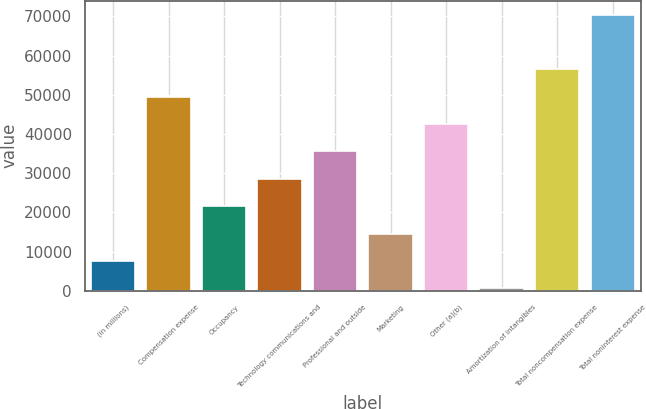<chart> <loc_0><loc_0><loc_500><loc_500><bar_chart><fcel>(in millions)<fcel>Compensation expense<fcel>Occupancy<fcel>Technology communications and<fcel>Professional and outside<fcel>Marketing<fcel>Other (a)(b)<fcel>Amortization of intangibles<fcel>Total noncompensation expense<fcel>Total noninterest expense<nl><fcel>7620<fcel>49518<fcel>21586<fcel>28569<fcel>35552<fcel>14603<fcel>42535<fcel>637<fcel>56501<fcel>70467<nl></chart> 